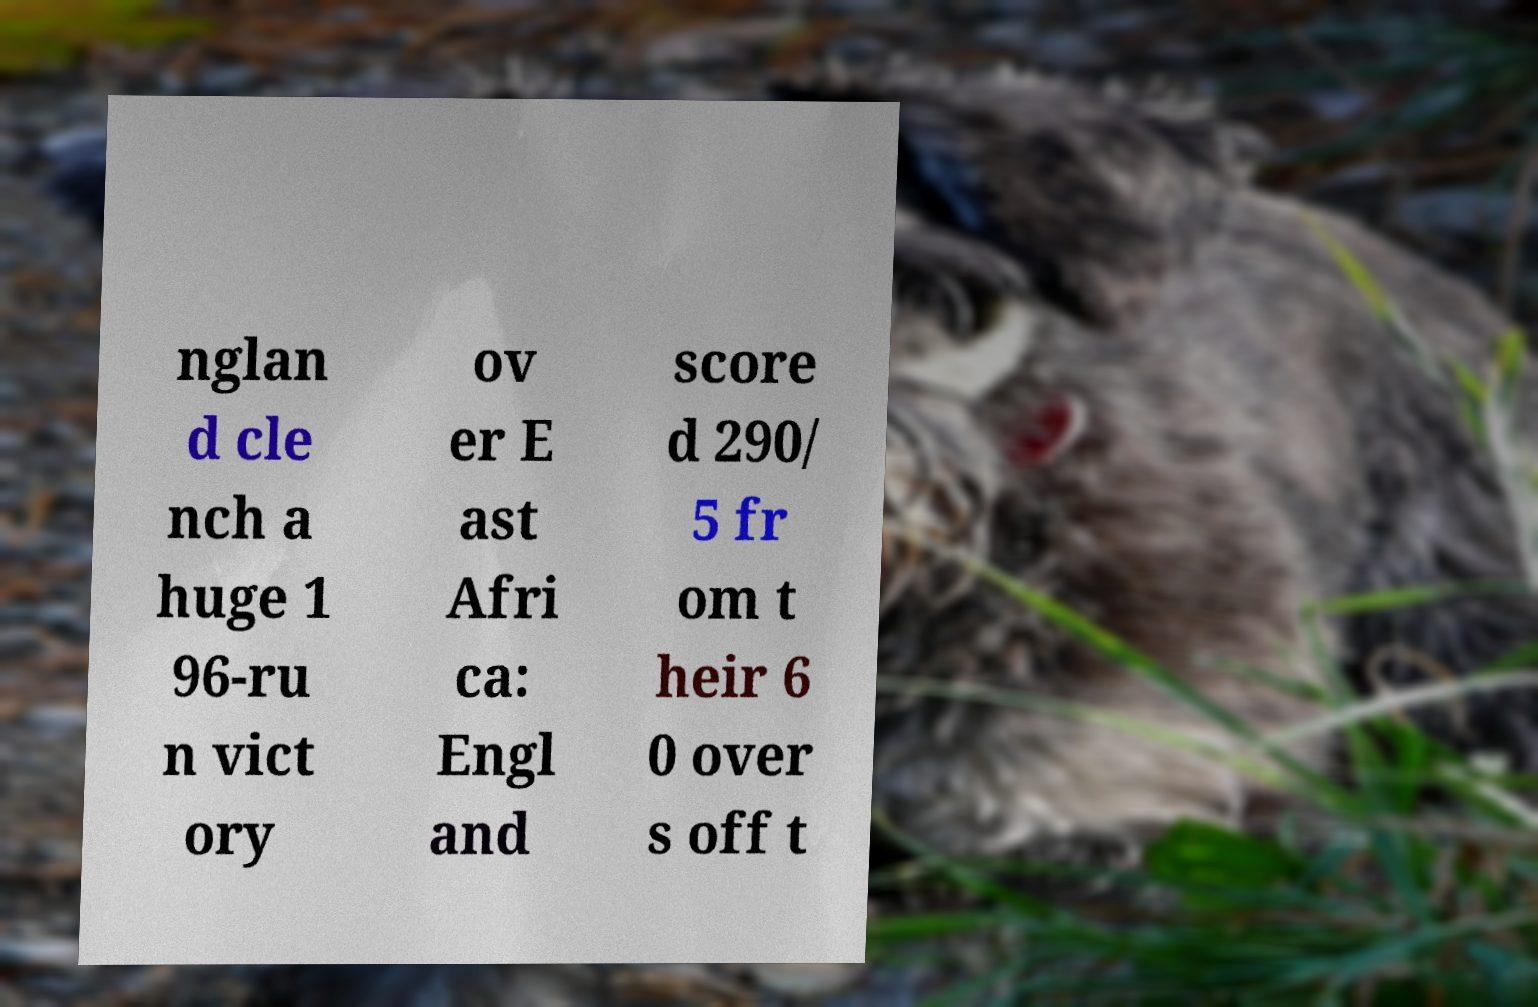Can you read and provide the text displayed in the image?This photo seems to have some interesting text. Can you extract and type it out for me? nglan d cle nch a huge 1 96-ru n vict ory ov er E ast Afri ca: Engl and score d 290/ 5 fr om t heir 6 0 over s off t 